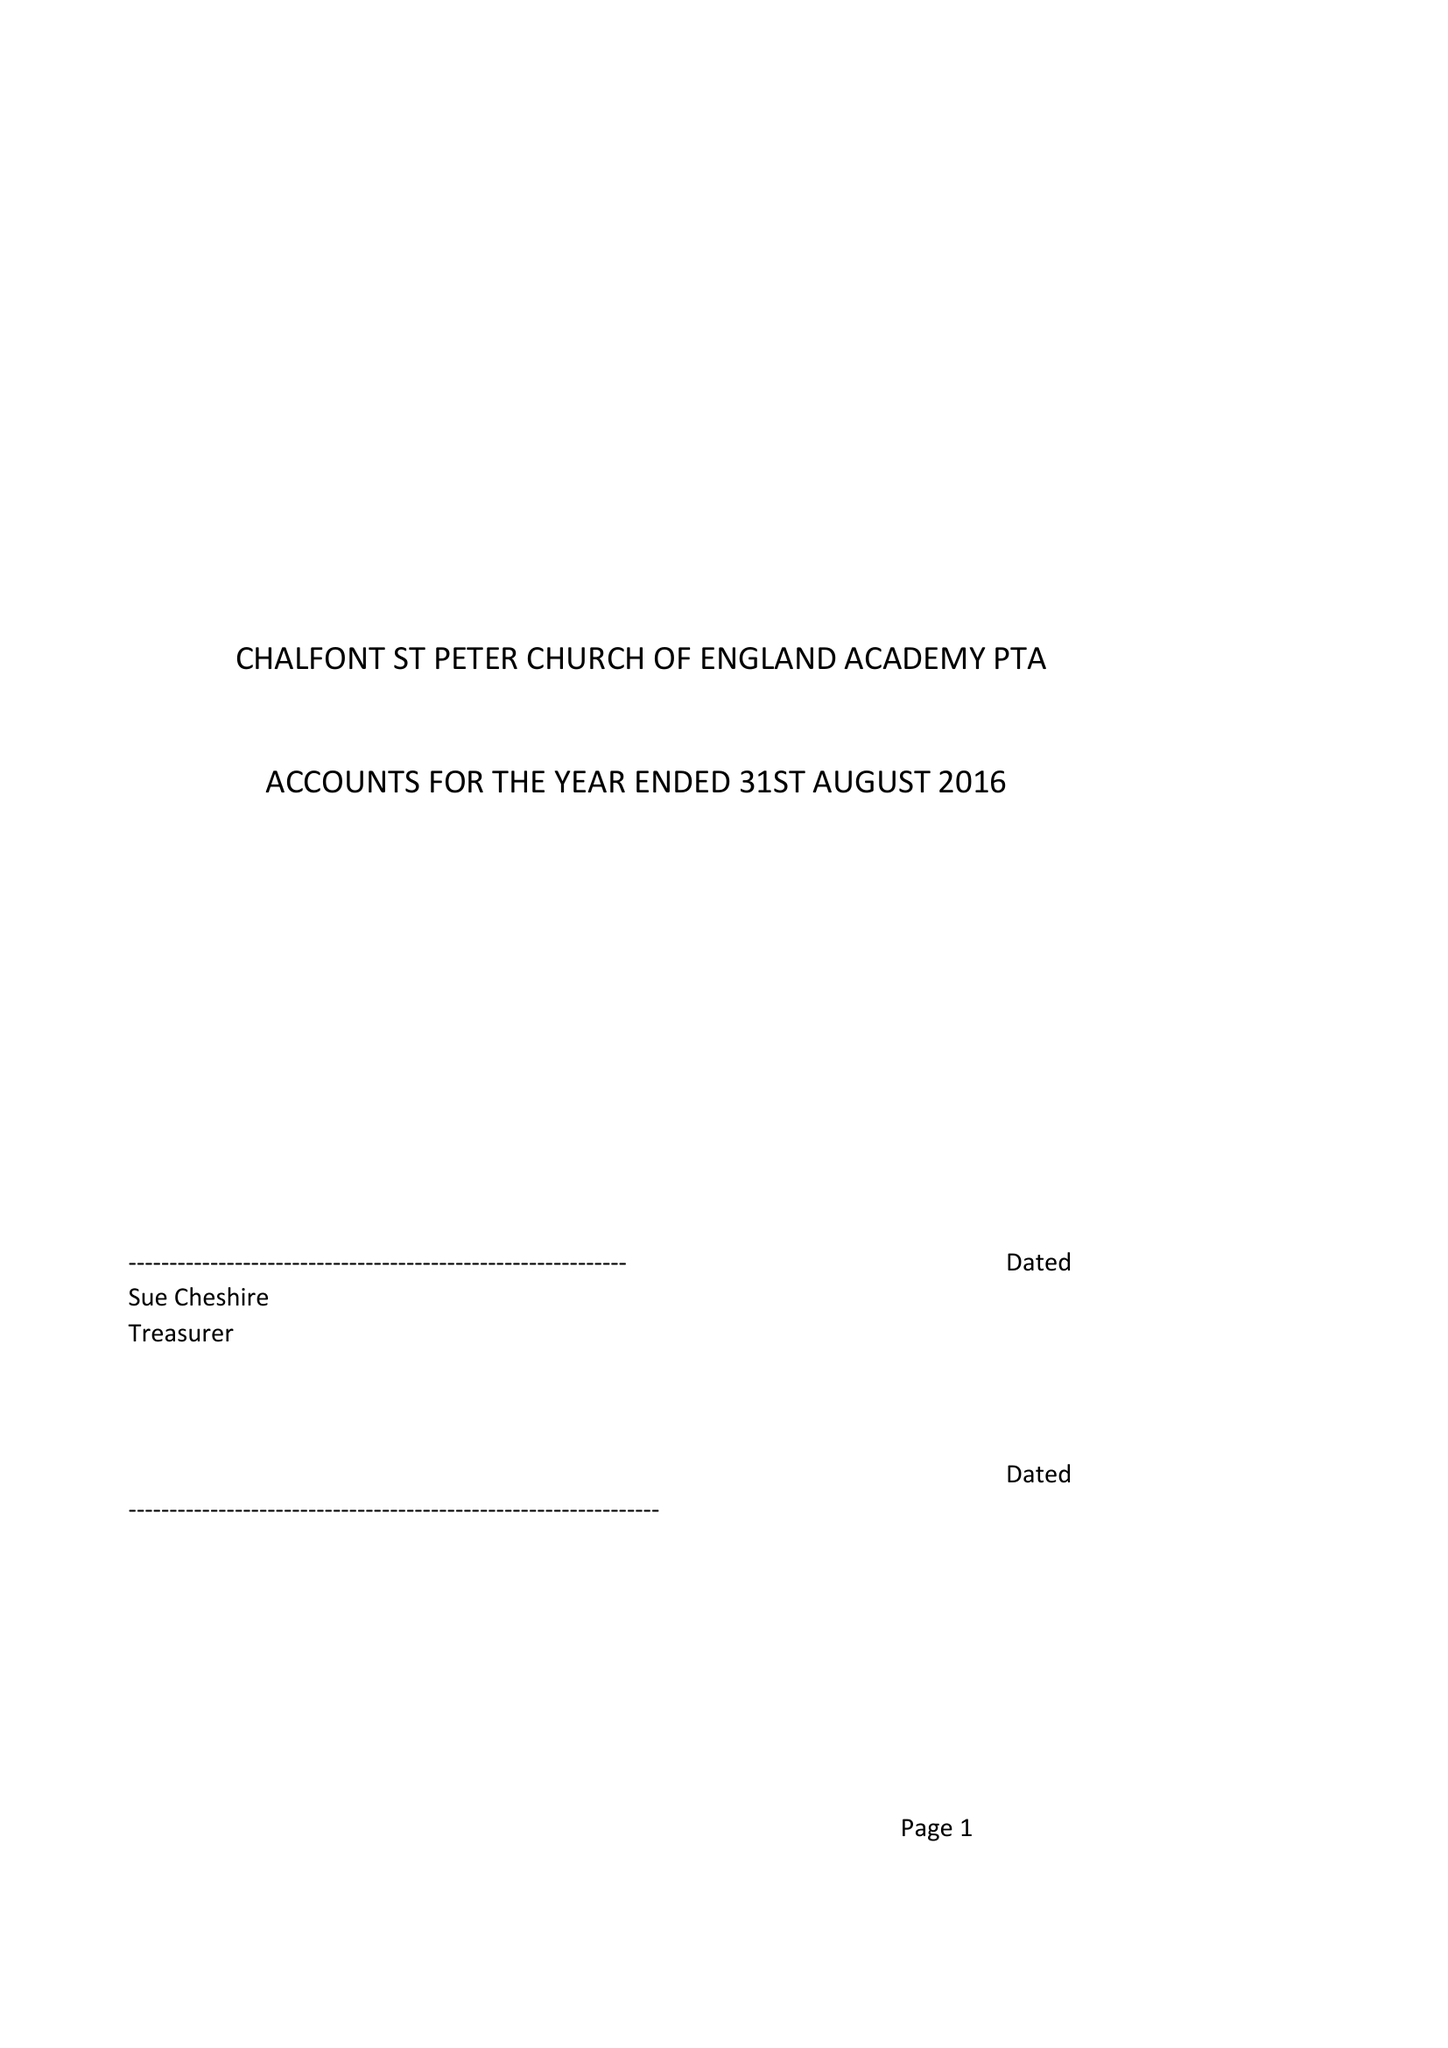What is the value for the charity_name?
Answer the question using a single word or phrase. Chalfont St Peter C Of E Academy Pta 